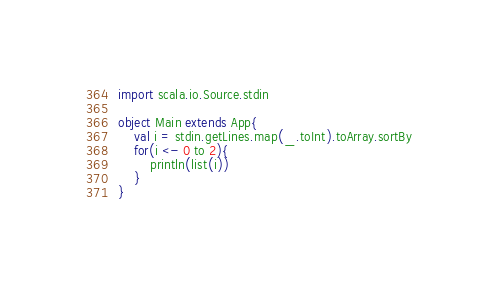Convert code to text. <code><loc_0><loc_0><loc_500><loc_500><_Scala_>import scala.io.Source.stdin

object Main extends App{
	val i = stdin.getLines.map(_.toInt).toArray.sortBy
	for(i <- 0 to 2){
		println(list(i))
	}
}</code> 